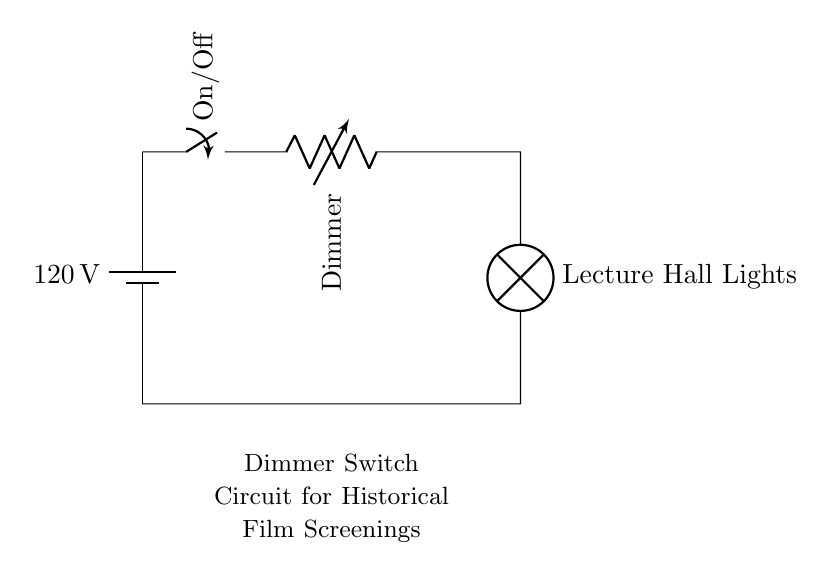What is the voltage in this circuit? The voltage is 120 volts, as indicated by the battery symbol in the diagram. It represents the power source connected to the circuit.
Answer: 120 volts What component is used to control the brightness of the lights? The component controlling brightness is the dimmer, represented by the variable resistor in the circuit. It adjusts the resistance and thereby the current reaching the lamp.
Answer: Dimmer What type of lights are connected to this circuit? The lights connected are labeled as "Lecture Hall Lights," indicating they are specifically intended for lighting in a lecture hall setting.
Answer: Lecture Hall Lights How many main components are there in this circuit? There are four main components: a battery, a switch, a dimmer, and the lights. Each plays a critical role in the functioning of the circuit.
Answer: Four What is the function of the switch in this circuit? The switch serves to turn the circuit on or off, allowing control over whether the electricity flows to the dimmer and the lights, enabling easier management of the lighting during screenings.
Answer: On/Off What effect does increasing the resistance of the dimmer have on the lights? Increasing the resistance of the dimmer reduces the current flowing to the lights, which decreases their brightness, allowing for better control of lighting during film screenings.
Answer: Decreases brightness 